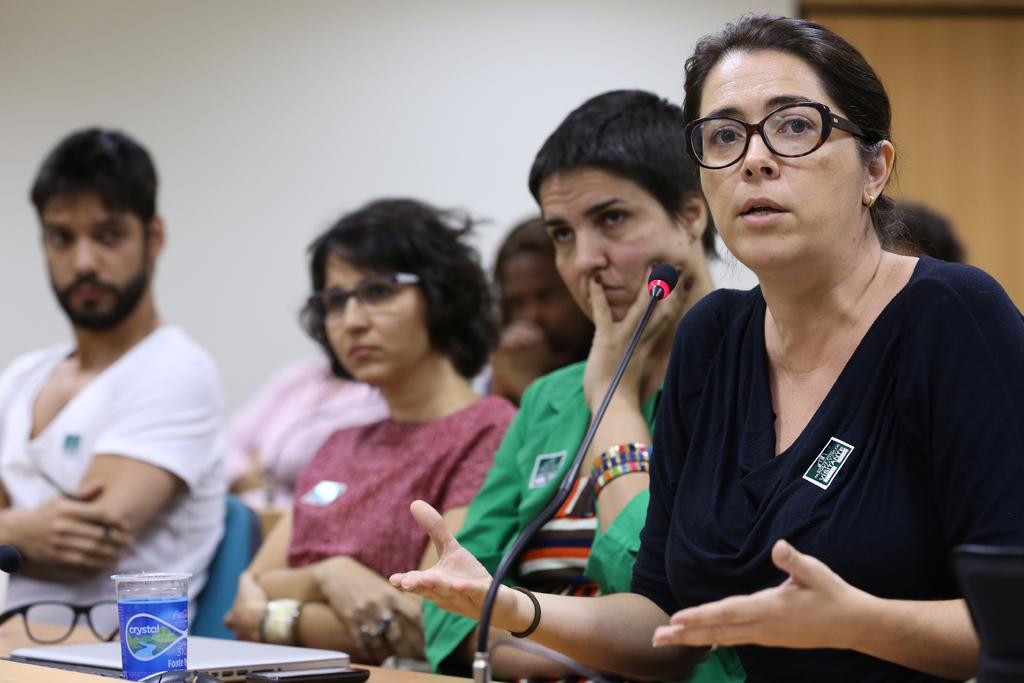Can you describe this image briefly? It is a conference there are some people sitting in front of a table and on the table there are spectacles,laptop and a glass. In the front a woman is talking something and there is a mic in front of the woman and in the background there is a white wall. 